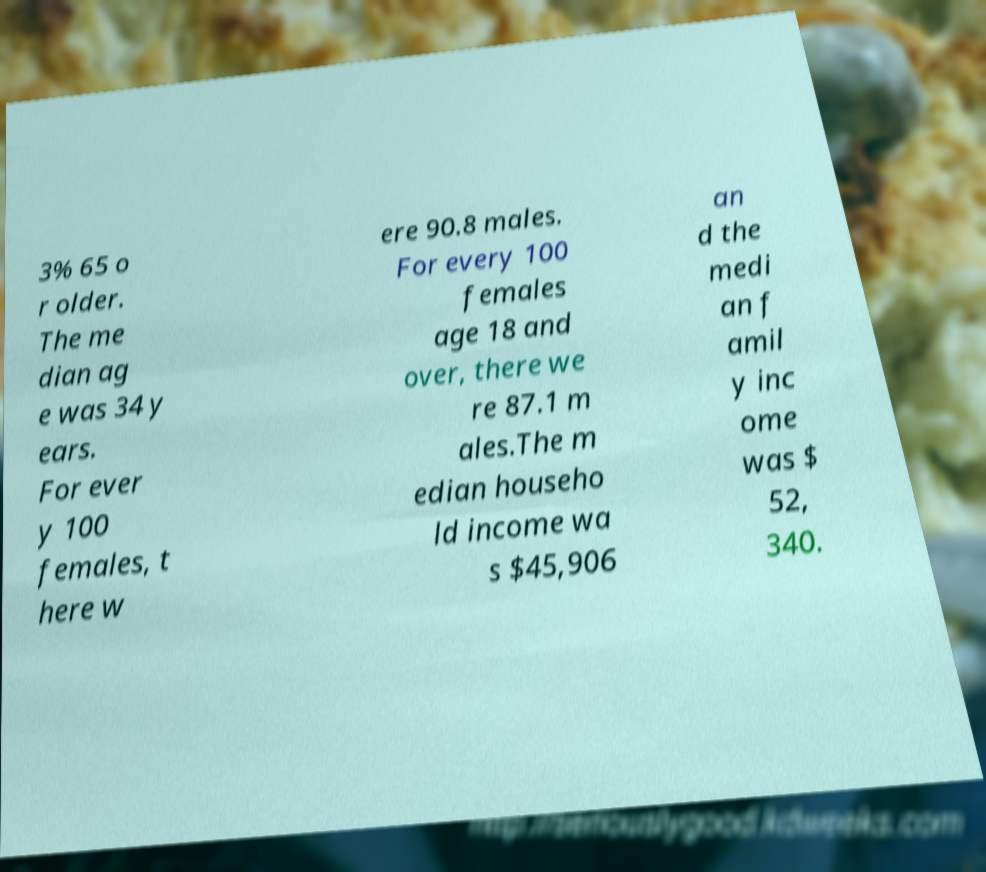Can you read and provide the text displayed in the image?This photo seems to have some interesting text. Can you extract and type it out for me? 3% 65 o r older. The me dian ag e was 34 y ears. For ever y 100 females, t here w ere 90.8 males. For every 100 females age 18 and over, there we re 87.1 m ales.The m edian househo ld income wa s $45,906 an d the medi an f amil y inc ome was $ 52, 340. 